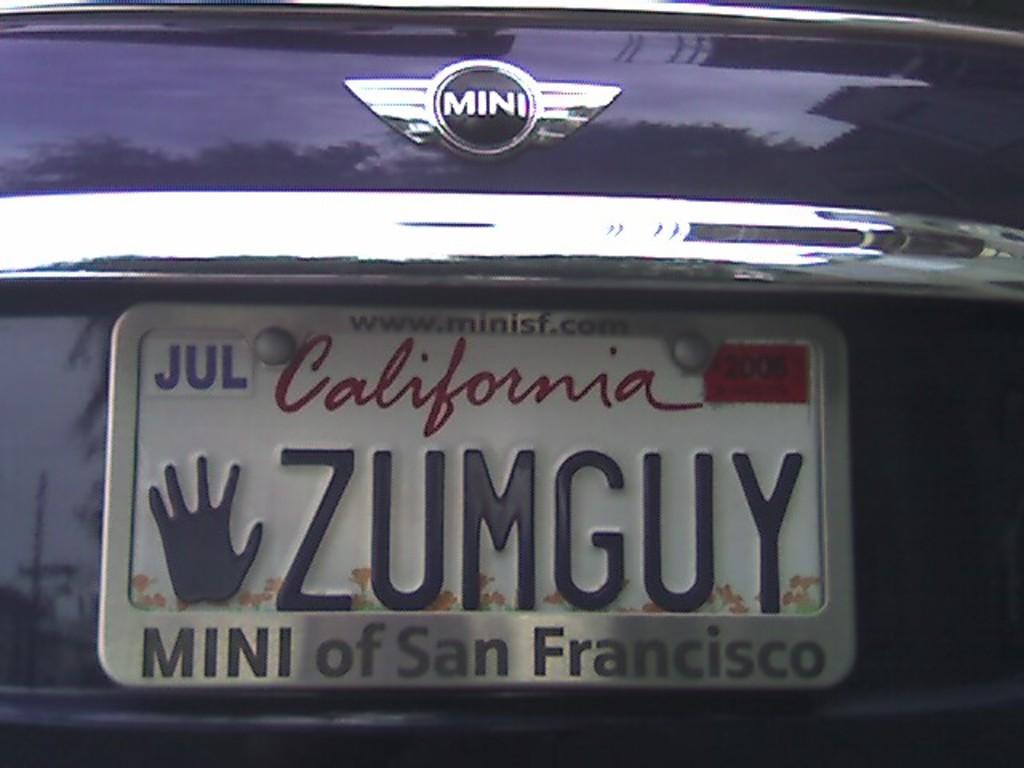<image>
Share a concise interpretation of the image provided. The mini car brand with a California tag on the back. 